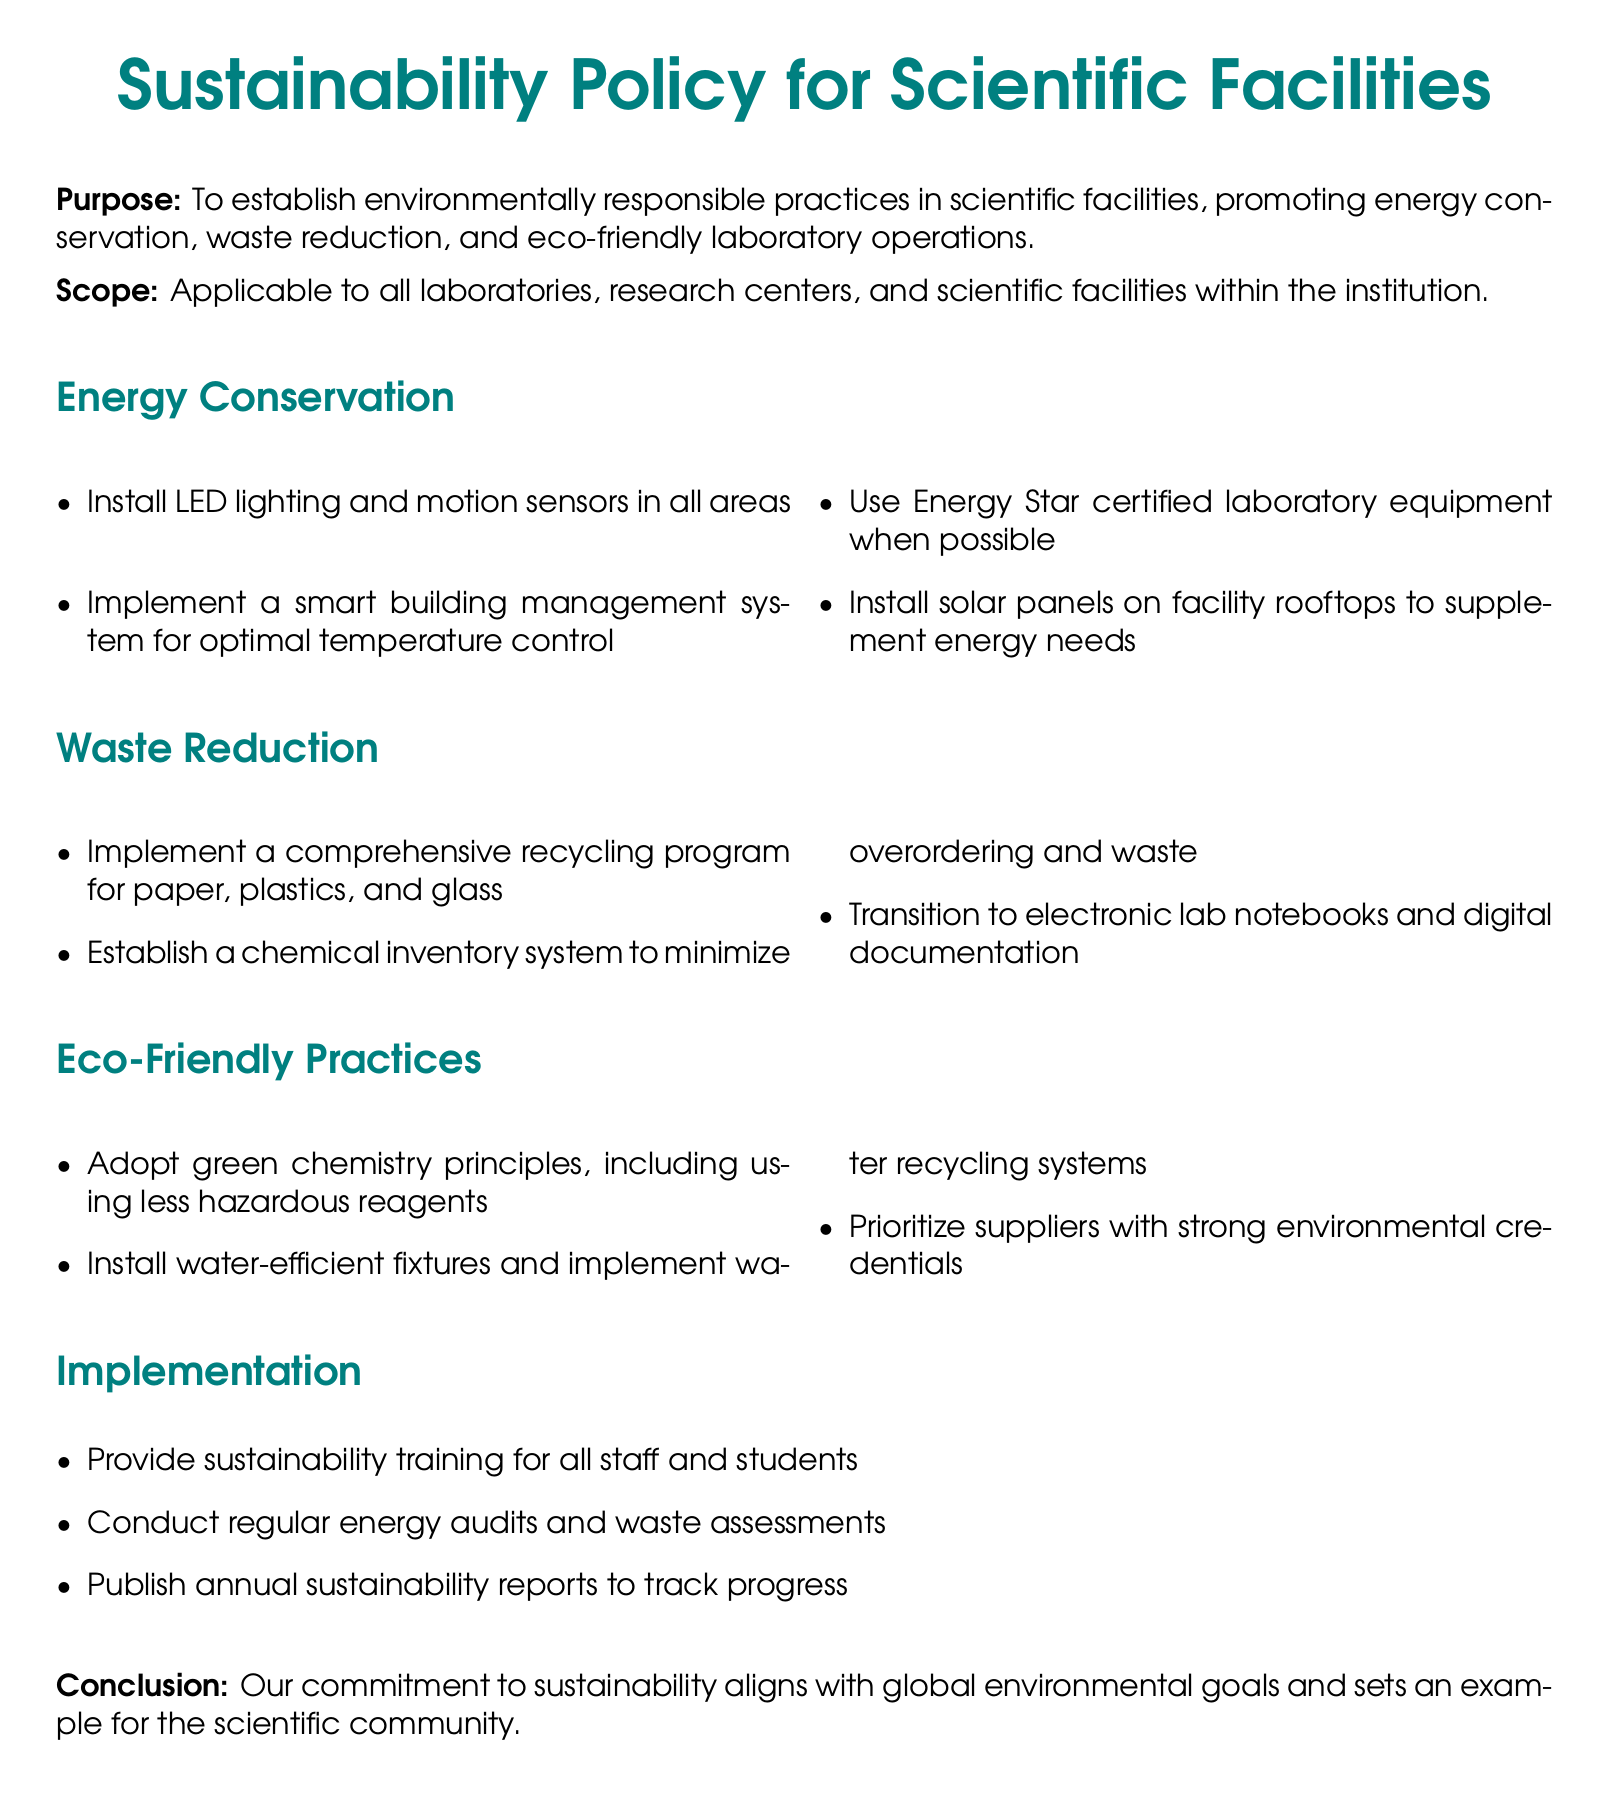What is the purpose of the sustainability policy? The purpose of the sustainability policy is to establish environmentally responsible practices in scientific facilities, promoting energy conservation, waste reduction, and eco-friendly laboratory operations.
Answer: To establish environmentally responsible practices What equipment is recommended to reduce energy usage? The document suggests using Energy Star certified laboratory equipment to minimize energy consumption.
Answer: Energy Star certified laboratory equipment What is one waste reduction strategy mentioned? Among the strategies, establishing a chemical inventory system is highlighted to minimize overordering and waste.
Answer: Chemical inventory system Which practice is encouraged to be eco-friendly in laboratories? Adopting green chemistry principles, including using less hazardous reagents, is mentioned as an eco-friendly practice.
Answer: Green chemistry principles What training is suggested for staff and students? Providing sustainability training for all staff and students is an essential recommendation for implementation.
Answer: Sustainability training How often should energy audits be conducted? Regular energy audits are to be conducted as part of the implementation strategy outlined in the policy.
Answer: Regularly What type of lighting should be installed according to the policy? The policy recommends installing LED lighting in all areas to enhance energy conservation efforts.
Answer: LED lighting What is the scope of the sustainability policy? The scope of the policy is applicable to all laboratories, research centers, and scientific facilities within the institution.
Answer: All laboratories, research centers, and scientific facilities What is one eco-friendly fixture suggested for installation? Installing water-efficient fixtures is one of the practices recommended under eco-friendly measures.
Answer: Water-efficient fixtures 